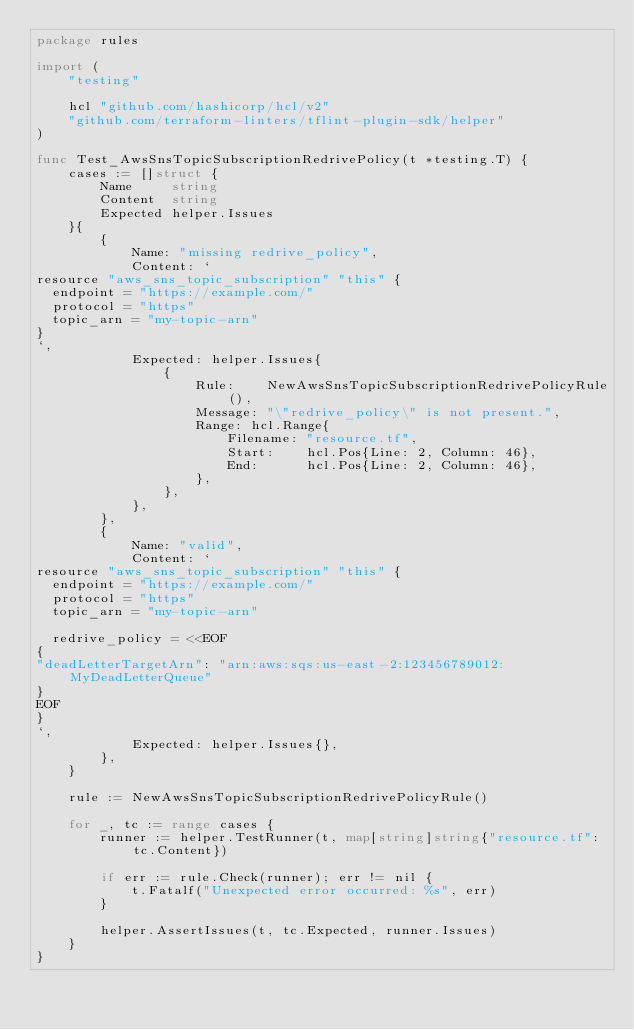Convert code to text. <code><loc_0><loc_0><loc_500><loc_500><_Go_>package rules

import (
	"testing"

	hcl "github.com/hashicorp/hcl/v2"
	"github.com/terraform-linters/tflint-plugin-sdk/helper"
)

func Test_AwsSnsTopicSubscriptionRedrivePolicy(t *testing.T) {
	cases := []struct {
		Name     string
		Content  string
		Expected helper.Issues
	}{
		{
			Name: "missing redrive_policy",
			Content: `
resource "aws_sns_topic_subscription" "this" {
  endpoint = "https://example.com/"
  protocol = "https"
  topic_arn = "my-topic-arn"
}
`,
			Expected: helper.Issues{
				{
					Rule:    NewAwsSnsTopicSubscriptionRedrivePolicyRule(),
					Message: "\"redrive_policy\" is not present.",
					Range: hcl.Range{
						Filename: "resource.tf",
						Start:    hcl.Pos{Line: 2, Column: 46},
						End:      hcl.Pos{Line: 2, Column: 46},
					},
				},
			},
		},
		{
			Name: "valid",
			Content: `
resource "aws_sns_topic_subscription" "this" {
  endpoint = "https://example.com/"
  protocol = "https"
  topic_arn = "my-topic-arn"

  redrive_policy = <<EOF
{
"deadLetterTargetArn": "arn:aws:sqs:us-east-2:123456789012:MyDeadLetterQueue"
}
EOF
}
`,
			Expected: helper.Issues{},
		},
	}

	rule := NewAwsSnsTopicSubscriptionRedrivePolicyRule()

	for _, tc := range cases {
		runner := helper.TestRunner(t, map[string]string{"resource.tf": tc.Content})

		if err := rule.Check(runner); err != nil {
			t.Fatalf("Unexpected error occurred: %s", err)
		}

		helper.AssertIssues(t, tc.Expected, runner.Issues)
	}
}
</code> 